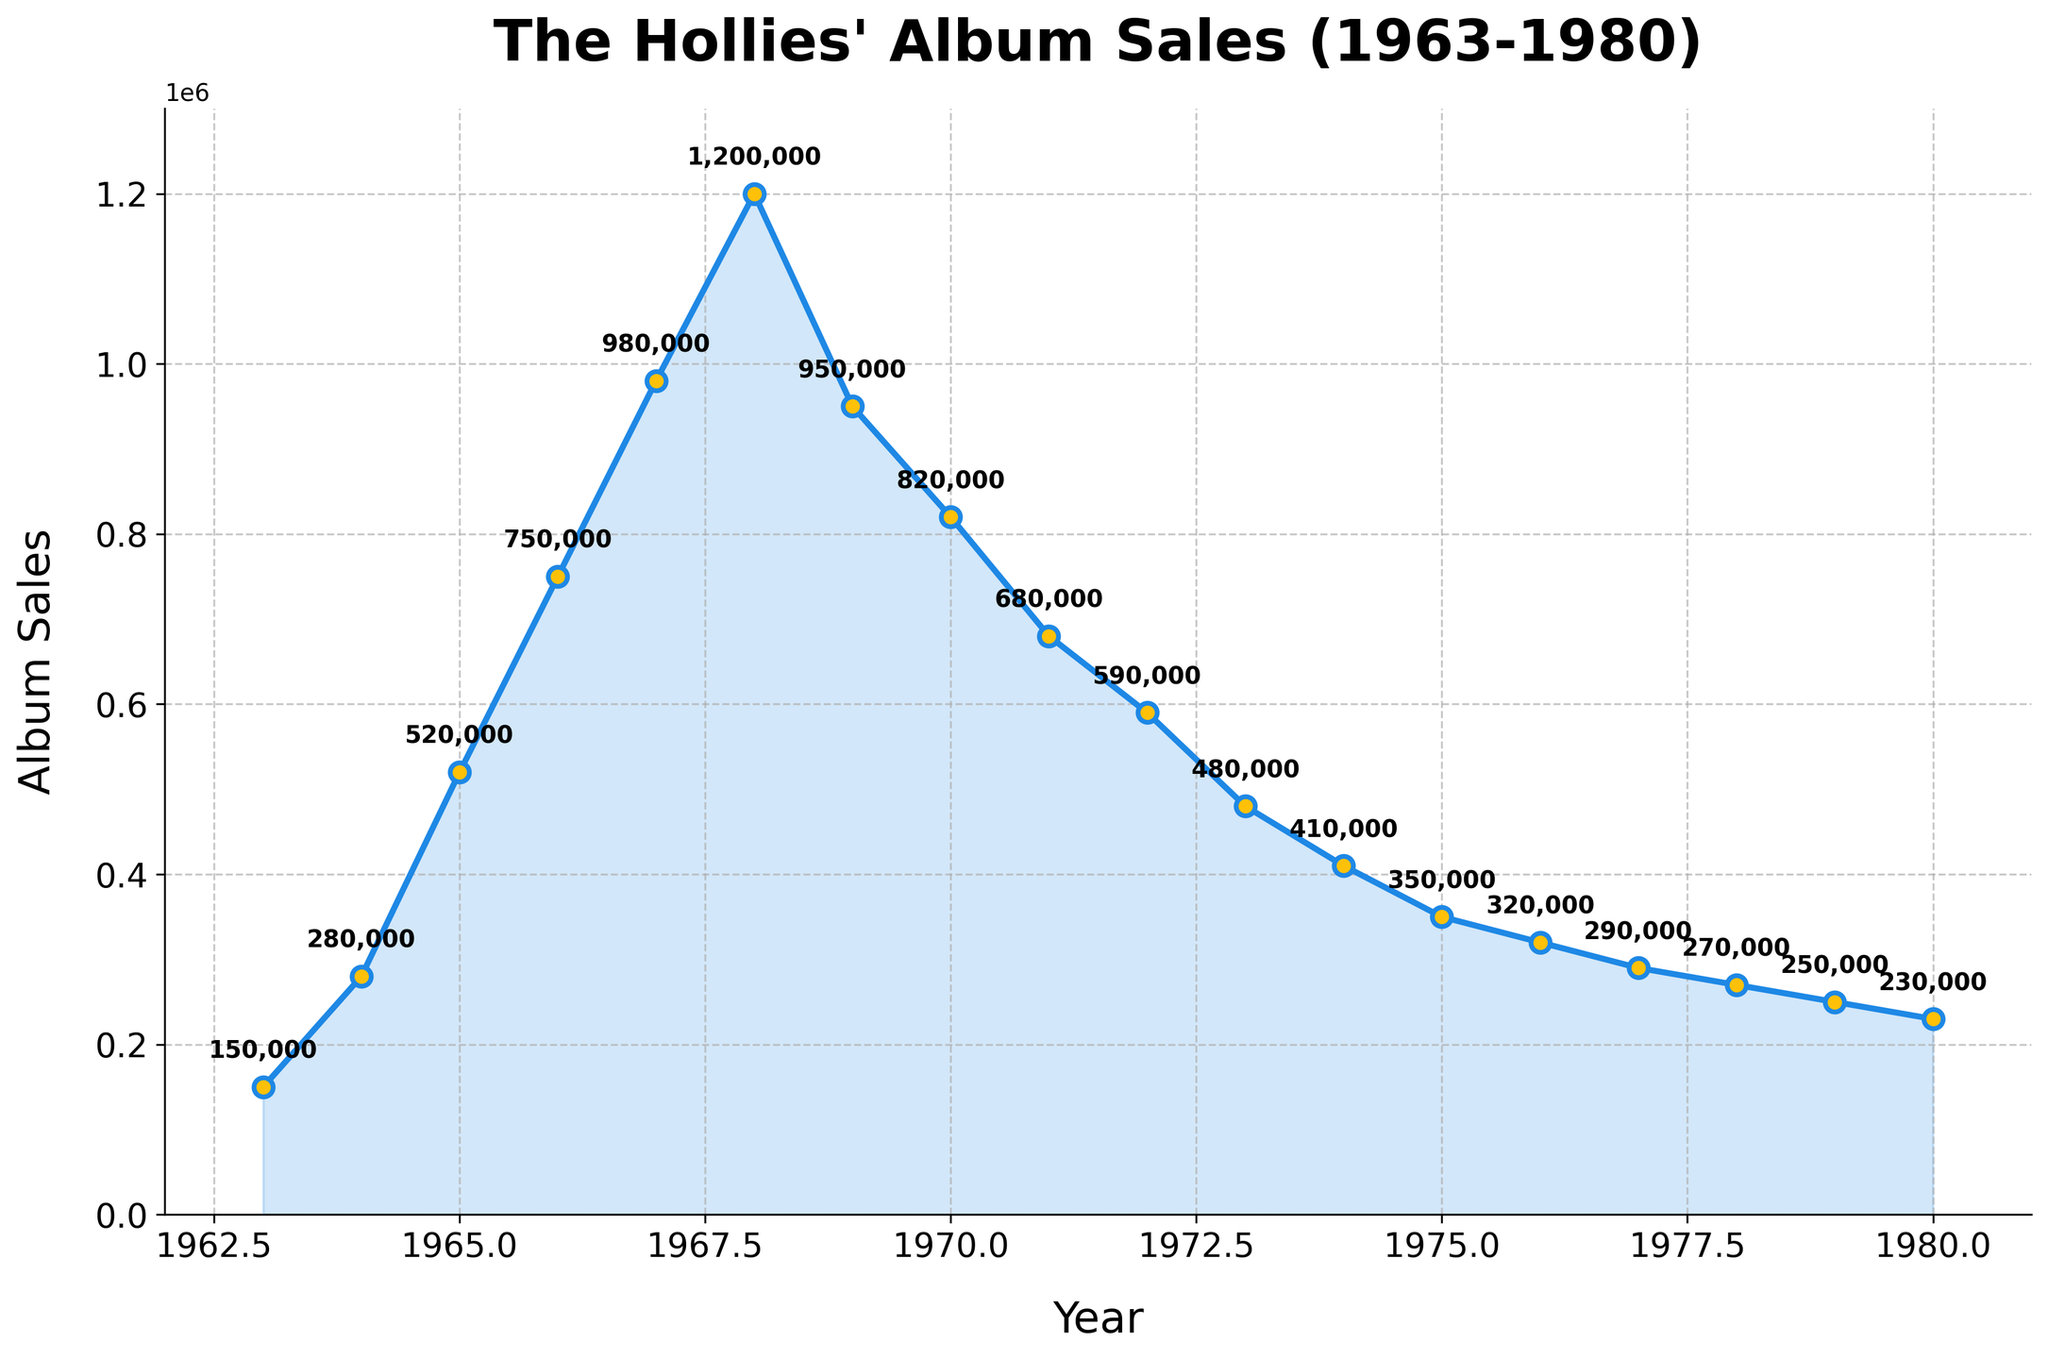What's the highest album sales recorded and in which year? The line chart shows the album sales per year, with the highest data point being 1,200,000 in the year 1968.
Answer: 1,200,000 in 1968 What's the total album sales from 1963 to 1980? Sum the album sales for each year from 1963 to 1980: 150,000 + 280,000 + 520,000 + 750,000 + 980,000 + 1,200,000 + 950,000 + 820,000 + 680,000 + 590,000 + 480,000 + 410,000 + 350,000 + 320,000 + 290,000 + 270,000 + 250,000 + 230,000 = 9,820,000.
Answer: 9,820,000 Which year showed a significant drop in album sales compared to the previous year? From 1968 to 1969, the sales decreased from 1,200,000 to 950,000, which is a drop of 250,000. This is the most significant drop on the line chart.
Answer: 1969 In what year did the album sales start to decline and then continued to do so until the end of the chart? The album sales started declining in 1968 and continued to decrease until 1980, with minor fluctuations.
Answer: 1968 How many years did the album sales stay above 500,000? The visual data points above 500,000 are: 1965, 1966, 1967, 1968, 1969, 1970, and 1971. Therefore, it stayed above 500,000 for 7 years.
Answer: 7 years By how much did album sales increase from 1963 to 1968? Subtract the album sales of 1963 from the sales in 1968: 1,200,000 - 150,000 = 1,050,000.
Answer: 1,050,000 Which two consecutive years showed the largest increase in album sales? Calculate the difference between each pair of consecutive years: 
1964-1963: 280,000 - 150,000 = 130,000 
1965-1964: 520,000 - 280,000 = 240,000 
1966-1965: 750,000 - 520,000 = 230,000 
1967-1966: 980,000 - 750,000 = 230,000 
1968-1967: 1,200,000 - 980,000 = 220,000 
1969-1968: 950,000 - 1,200,000 = -250,000 
1970-1969: 820,000 - 950,000 = -130,000 
1971-1970: 680,000 - 820,000 = -140,000 
1972-1971: 590,000 - 680,000 = -90,000 
1973-1972: 480,000 - 590,000 = -110,000 
1974-1973: 410,000 - 480,000 = -70,000 
1975-1974: 350,000 - 410,000 = -60,000 
1976-1975: 320,000 - 350,000 = -30,000 
1977-1976: 290,000 - 320,000 = -30,000 
1978-1977: 270,000 - 290,000 = -20,000 
1979-1978: 250,000 - 270,000 = -20,000 
1980-1979: 230,000 - 250,000 = -20,000 
The largest increase was from 1964 to 1965, which is 240,000.
Answer: 1964-1965 From which year did the album sales consistently stay below 500,000? Album sales were consistently below 500,000 from 1973 onwards.
Answer: 1973 